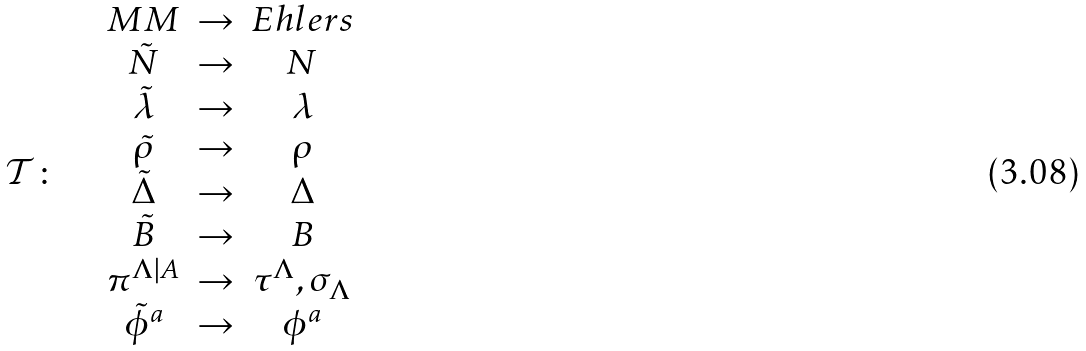Convert formula to latex. <formula><loc_0><loc_0><loc_500><loc_500>\mathcal { T } \colon \quad \begin{array} { c c c } M M & \rightarrow & E h l e r s \\ \tilde { N } & \rightarrow & N \\ \tilde { \lambda } & \rightarrow & \lambda \\ \tilde { \rho } & \rightarrow & \rho \\ \tilde { \Delta } & \rightarrow & \Delta \\ \tilde { B } & \rightarrow & B \\ \pi ^ { \Lambda | A } & \rightarrow & \tau ^ { \Lambda } , \sigma _ { \Lambda } \\ \tilde { \phi } ^ { a } & \rightarrow & \phi ^ { a } \end{array}</formula> 